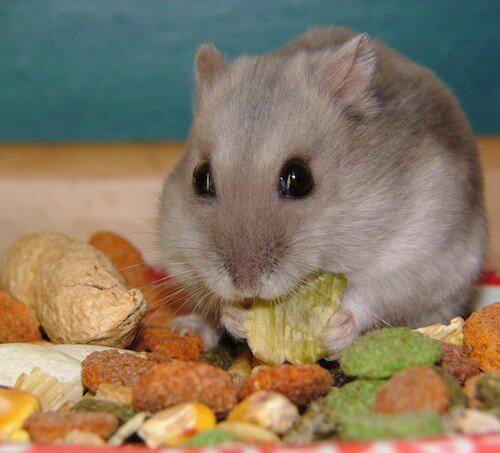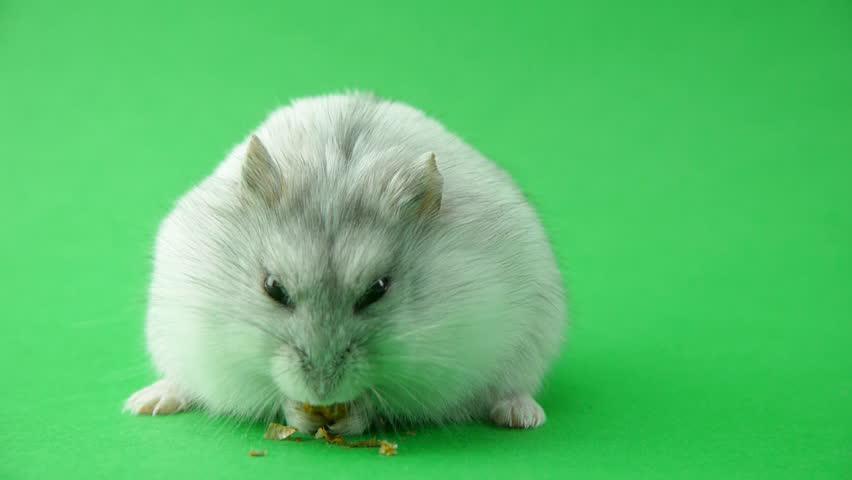The first image is the image on the left, the second image is the image on the right. Considering the images on both sides, is "The rodent is sitting in its food in one of the images." valid? Answer yes or no. Yes. The first image is the image on the left, the second image is the image on the right. Evaluate the accuracy of this statement regarding the images: "An image shows a pet rodent holding an orange food item in both front paws.". Is it true? Answer yes or no. No. 